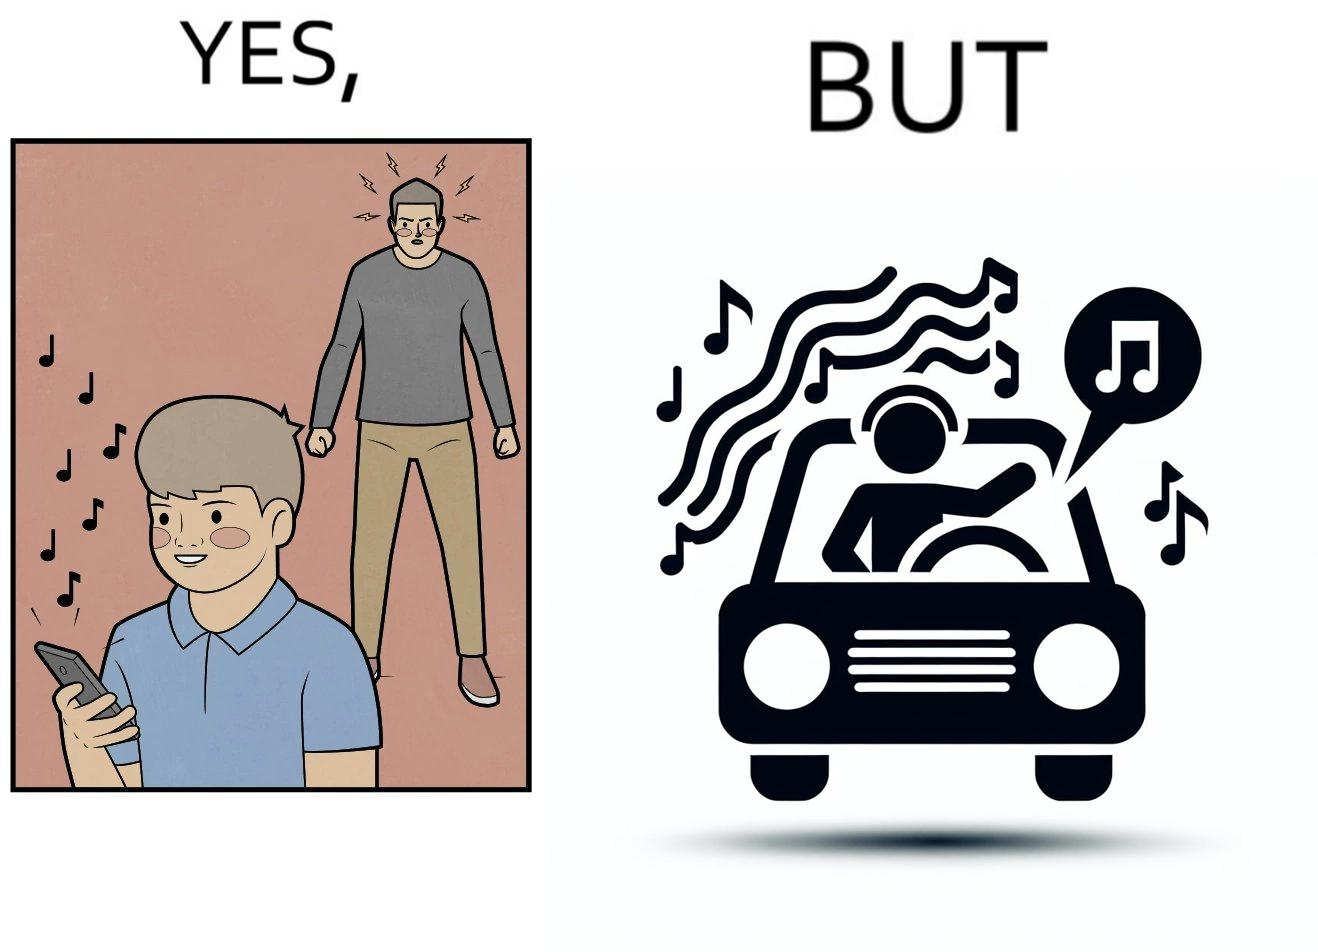Is this a satirical image? Yes, this image is satirical. 